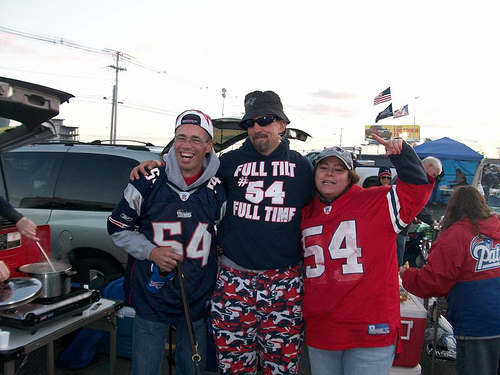<image>
Is the person in front of the van? Yes. The person is positioned in front of the van, appearing closer to the camera viewpoint. Where is the man in relation to the woman? Is it to the right of the woman? No. The man is not to the right of the woman. The horizontal positioning shows a different relationship. 